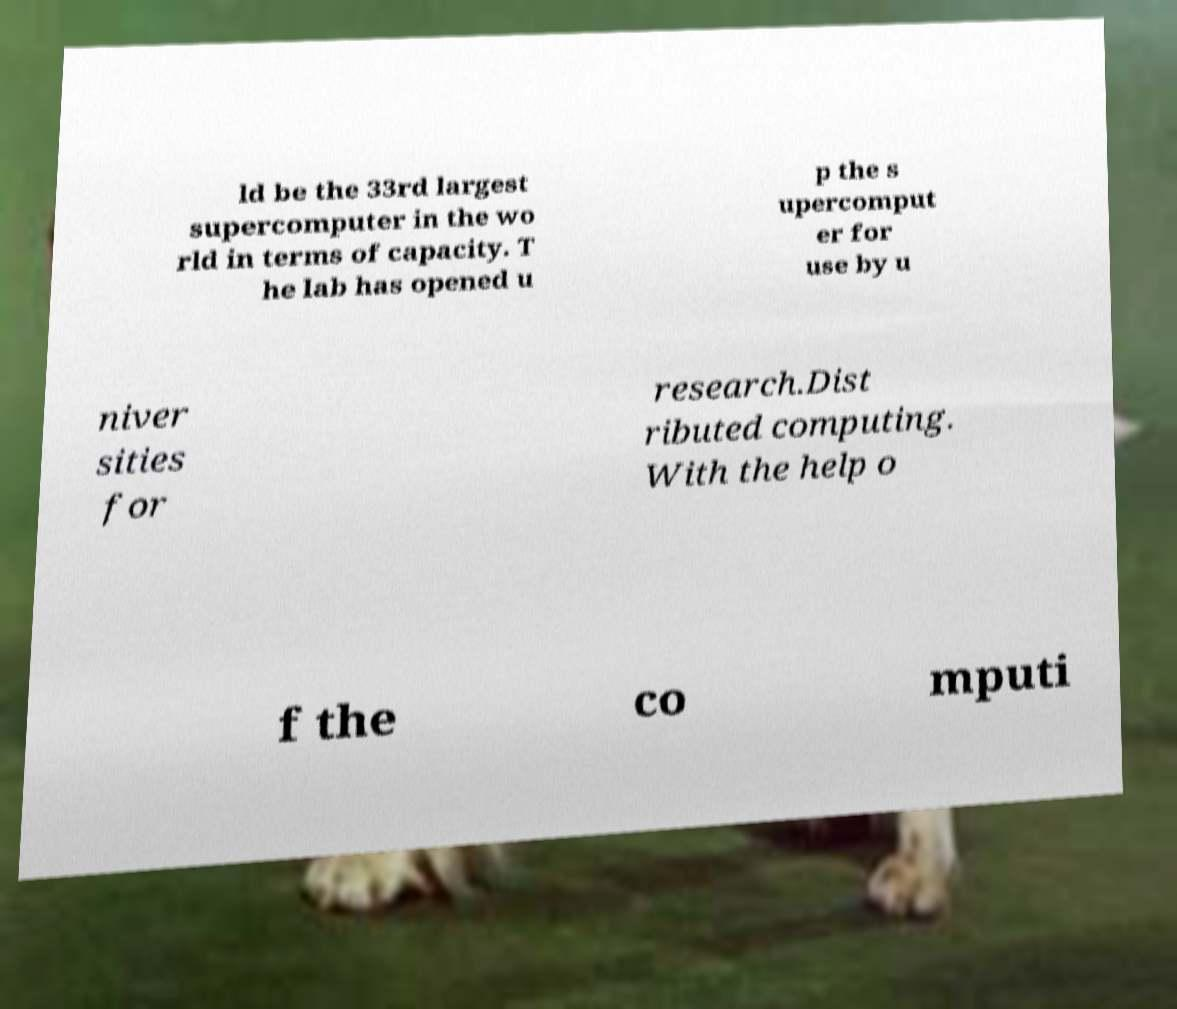Could you extract and type out the text from this image? ld be the 33rd largest supercomputer in the wo rld in terms of capacity. T he lab has opened u p the s upercomput er for use by u niver sities for research.Dist ributed computing. With the help o f the co mputi 